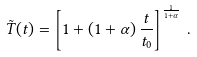Convert formula to latex. <formula><loc_0><loc_0><loc_500><loc_500>\tilde { T } ( t ) = \left [ 1 + \left ( 1 + \alpha \right ) \frac { t } { t _ { 0 } } \right ] ^ { \frac { 1 } { 1 + \alpha } } \, .</formula> 